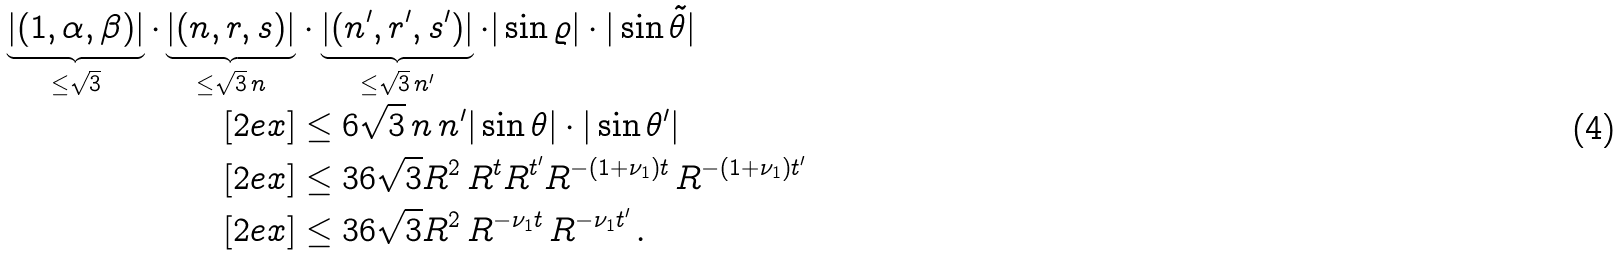<formula> <loc_0><loc_0><loc_500><loc_500>\underbrace { | ( 1 , \alpha , \beta ) | } _ { \leq \sqrt { 3 } } \cdot \underbrace { | ( n , r , s ) | } _ { \leq \sqrt { 3 } \, n } & \cdot \underbrace { | ( n ^ { \prime } , r ^ { \prime } , s ^ { \prime } ) | } _ { \leq \sqrt { 3 } \, n ^ { \prime } } \cdot | \sin \varrho | \cdot | \sin \tilde { \theta } | \\ [ 2 e x ] & \leq 6 \sqrt { 3 } \, n \, n ^ { \prime } | \sin \theta | \cdot | \sin \theta ^ { \prime } | \\ [ 2 e x ] & \leq 3 6 \sqrt { 3 } R ^ { 2 } \, R ^ { t } R ^ { t ^ { \prime } } R ^ { - ( 1 + \nu _ { 1 } ) t } \, R ^ { - ( 1 + \nu _ { 1 } ) t ^ { \prime } } \\ [ 2 e x ] & \leq 3 6 \sqrt { 3 } R ^ { 2 } \, R ^ { - \nu _ { 1 } t } \, R ^ { - \nu _ { 1 } t ^ { \prime } } \, .</formula> 